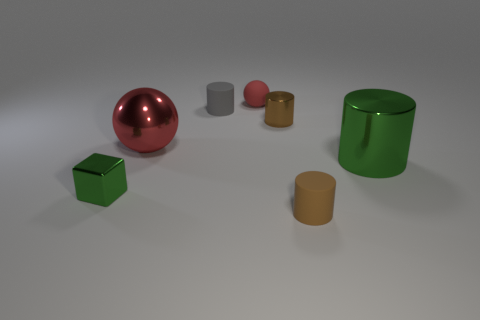Do the matte thing that is in front of the gray rubber thing and the large object that is on the left side of the big green metallic cylinder have the same shape?
Give a very brief answer. No. What number of small gray blocks are there?
Make the answer very short. 0. What shape is the red thing that is made of the same material as the green cylinder?
Provide a succinct answer. Sphere. Are there any other things that are the same color as the large shiny ball?
Offer a very short reply. Yes. Do the small matte sphere and the small shiny thing right of the gray rubber cylinder have the same color?
Keep it short and to the point. No. Is the number of tiny cubes that are behind the small green cube less than the number of large yellow metal objects?
Provide a succinct answer. No. There is a tiny cylinder left of the tiny matte ball; what is it made of?
Provide a short and direct response. Rubber. How many other things are the same size as the rubber ball?
Your answer should be very brief. 4. Does the red metallic object have the same size as the brown cylinder that is in front of the green block?
Your answer should be very brief. No. What shape is the green metallic object that is behind the green thing to the left of the brown thing that is to the right of the brown metallic object?
Offer a very short reply. Cylinder. 